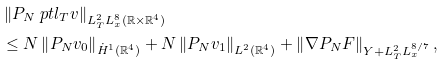<formula> <loc_0><loc_0><loc_500><loc_500>& \left \| P _ { N } \ p t l _ { T } v \right \| _ { L _ { T } ^ { 2 } L _ { x } ^ { 8 } ( \mathbb { R } \times \mathbb { R } ^ { 4 } ) } \\ & \leq N \left \| P _ { N } v _ { 0 } \right \| _ { \dot { H } ^ { 1 } ( \mathbb { R } ^ { 4 } ) } + N \left \| P _ { N } v _ { 1 } \right \| _ { L ^ { 2 } ( \mathbb { R } ^ { 4 } ) } + \left \| \nabla P _ { N } F \right \| _ { Y + L _ { T } ^ { 2 } L _ { x } ^ { 8 / 7 } } ,</formula> 